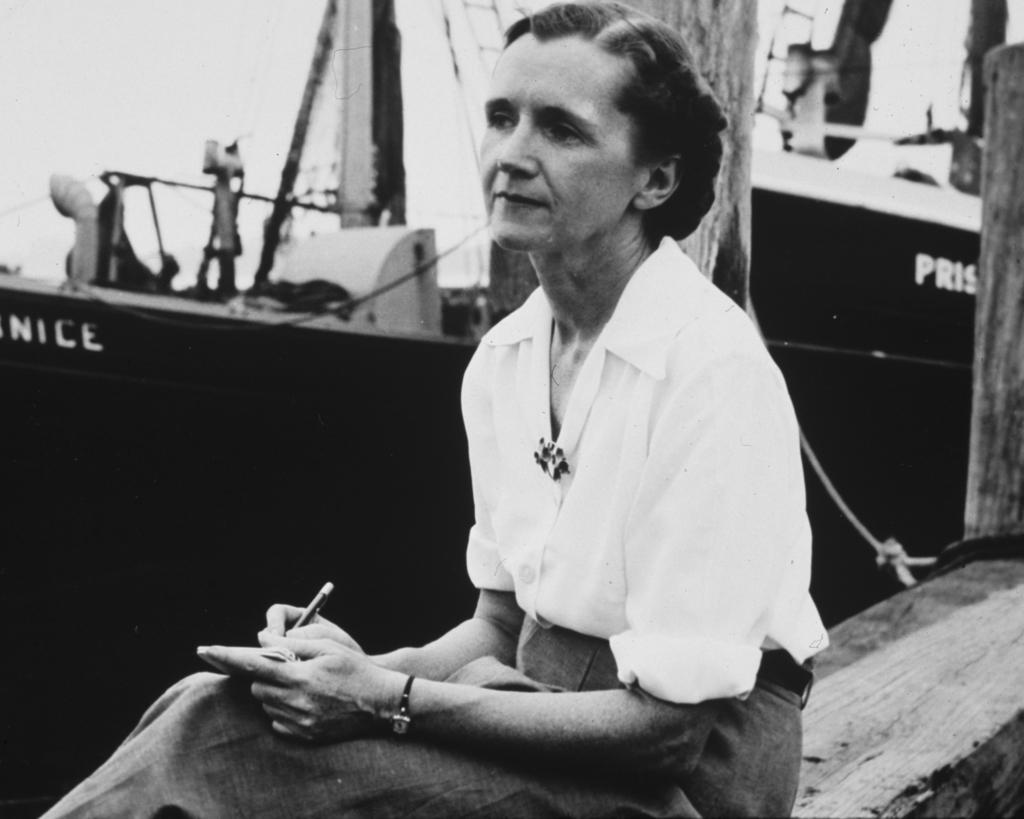What is the color scheme of the image? The image is black and white. Who is present in the image? There is a woman in the image. What is the woman holding in her hand? The woman is holding a pen and another object. What can be seen in the background of the image? There are wooden objects, a rope, a boat, and the sky visible in the background. What type of joke is the woman telling in the image? There is no indication in the image that the woman is telling a joke, as the facts provided do not mention any such activity. 